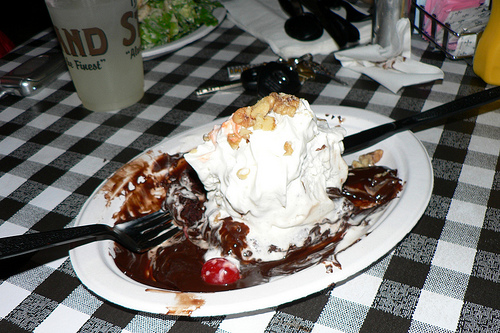<image>
Is the fork next to the plate? No. The fork is not positioned next to the plate. They are located in different areas of the scene. Is the cherry on the cup? No. The cherry is not positioned on the cup. They may be near each other, but the cherry is not supported by or resting on top of the cup. 